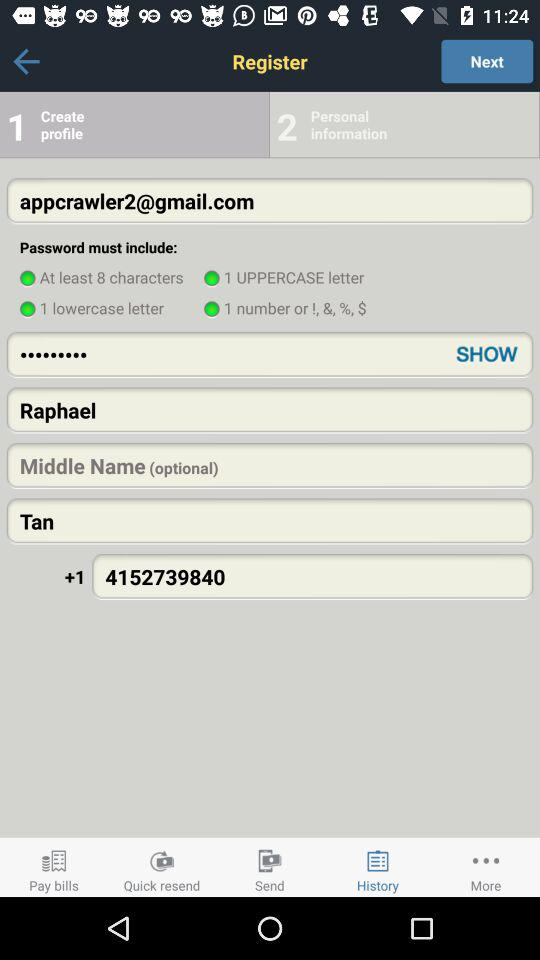What is the email address? The email address is appcrawler2@gmail.com. 